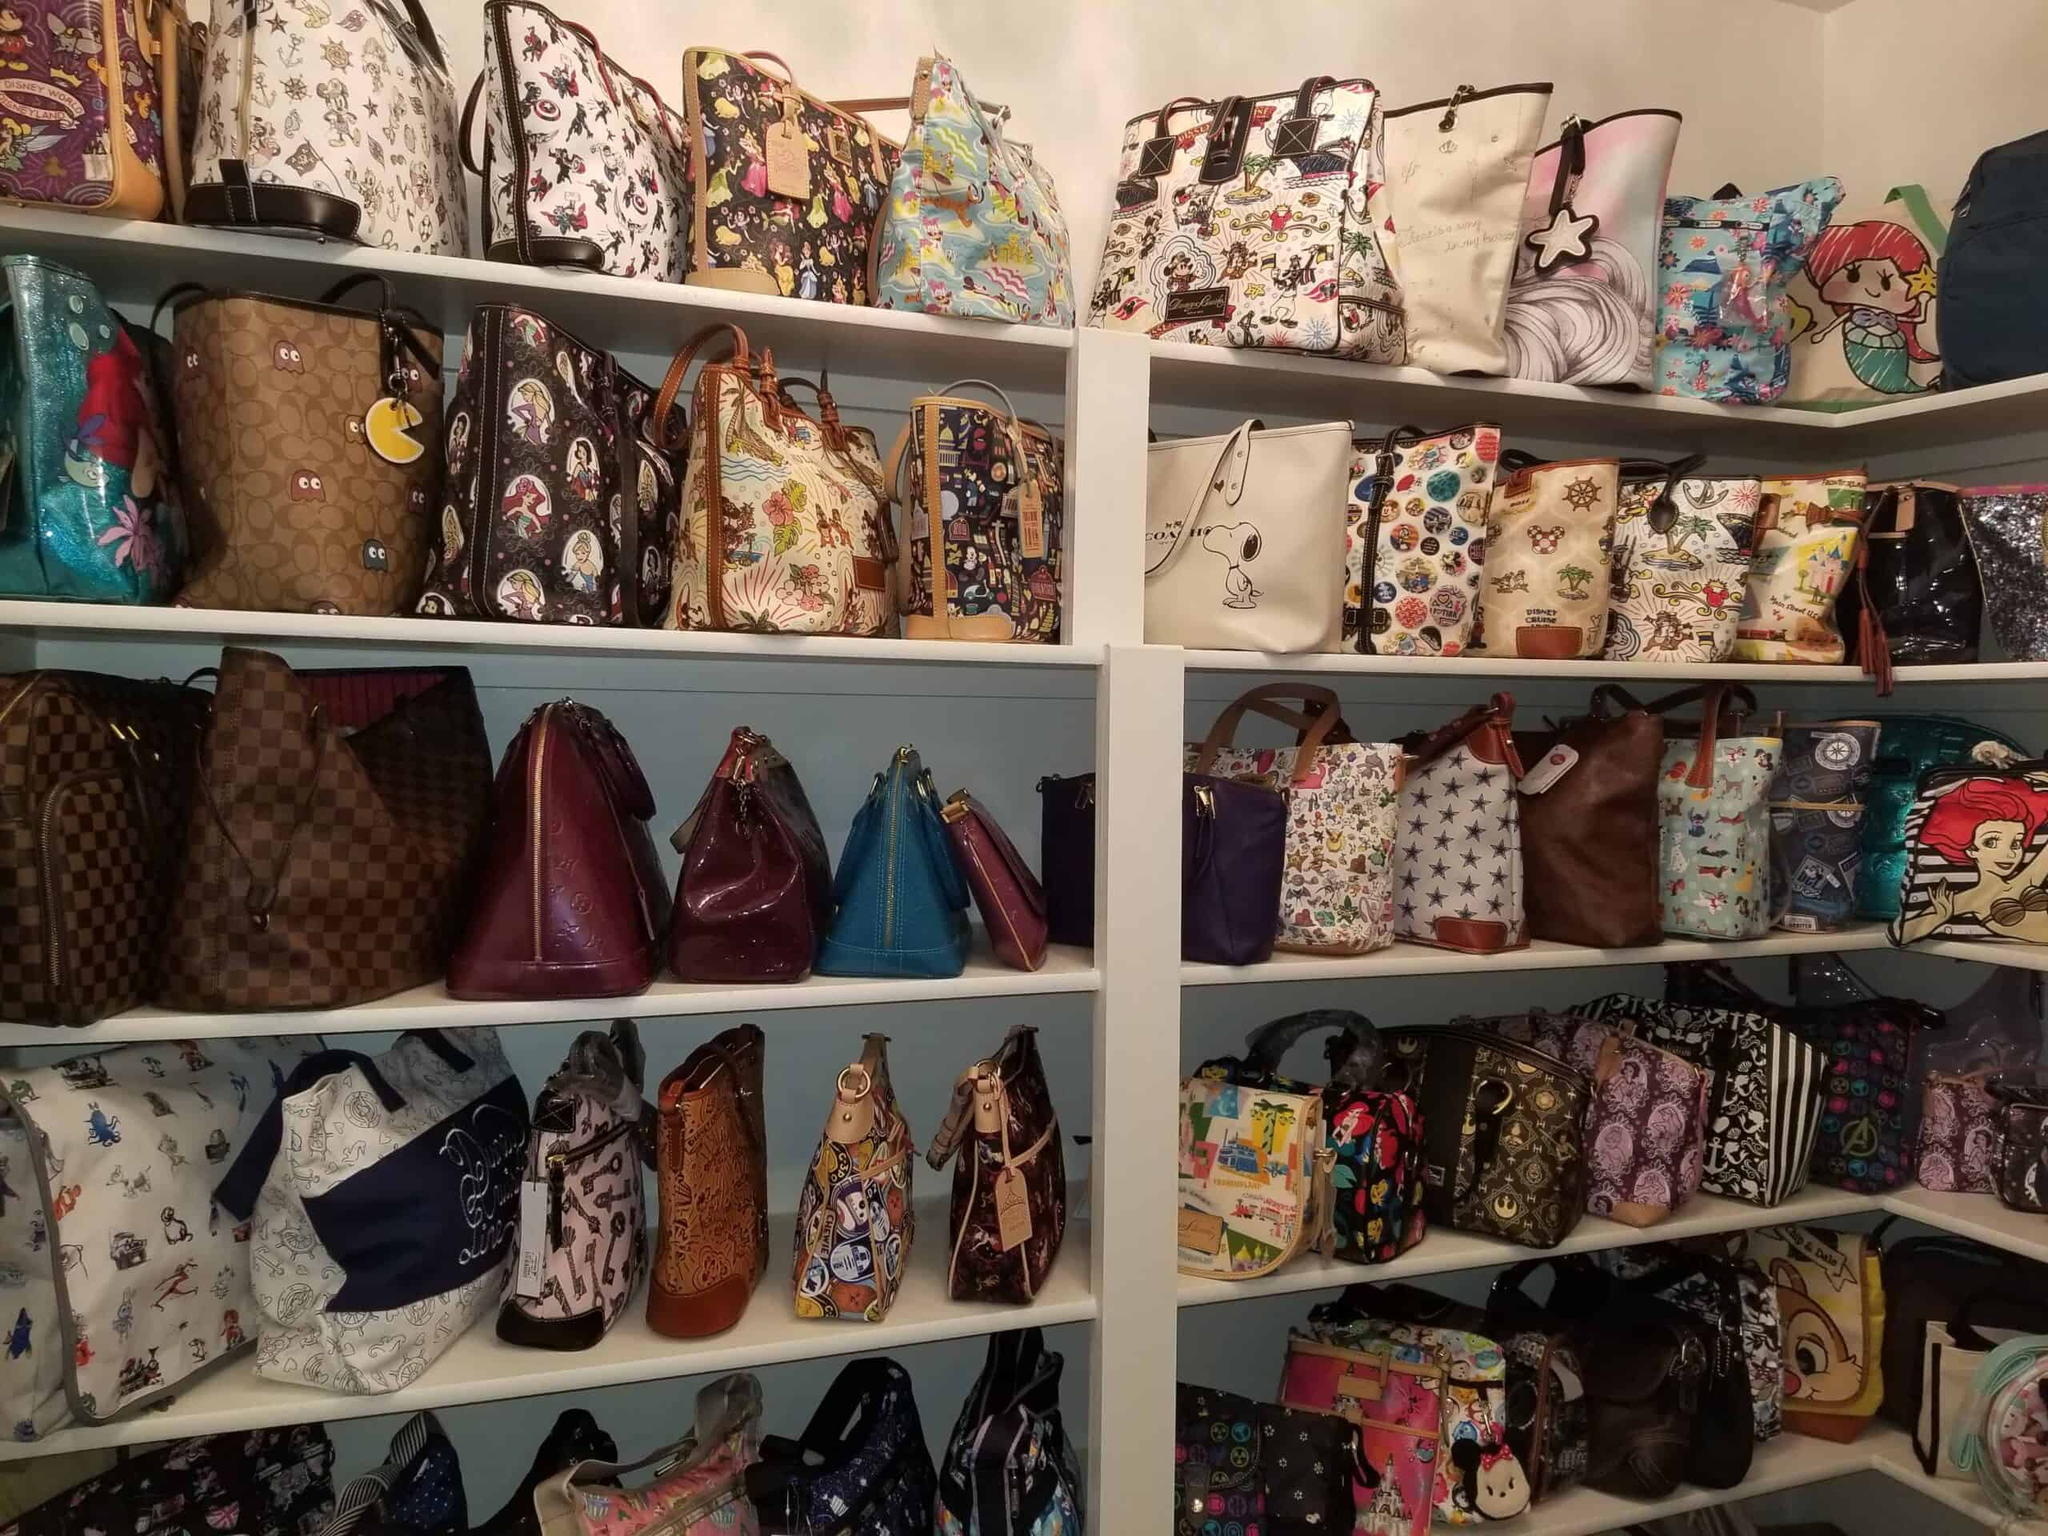Describe a fun story or scenario involving one of the themed bags! Imagine the bag featuring Ariel from 'The Little Mermaid' coming to life and joining her underwater friends for a grand adventure. The bag turns into a magical underwater chest, holding treasures and secrets from the ocean. One day, it gets swept away to the shore, where a young girl finds it and discovers it to be her portal to Atlantis. The bag's vibrant colors and intricate details make the adventure even more enchanting, with every zipper unlocking a new surprise. 